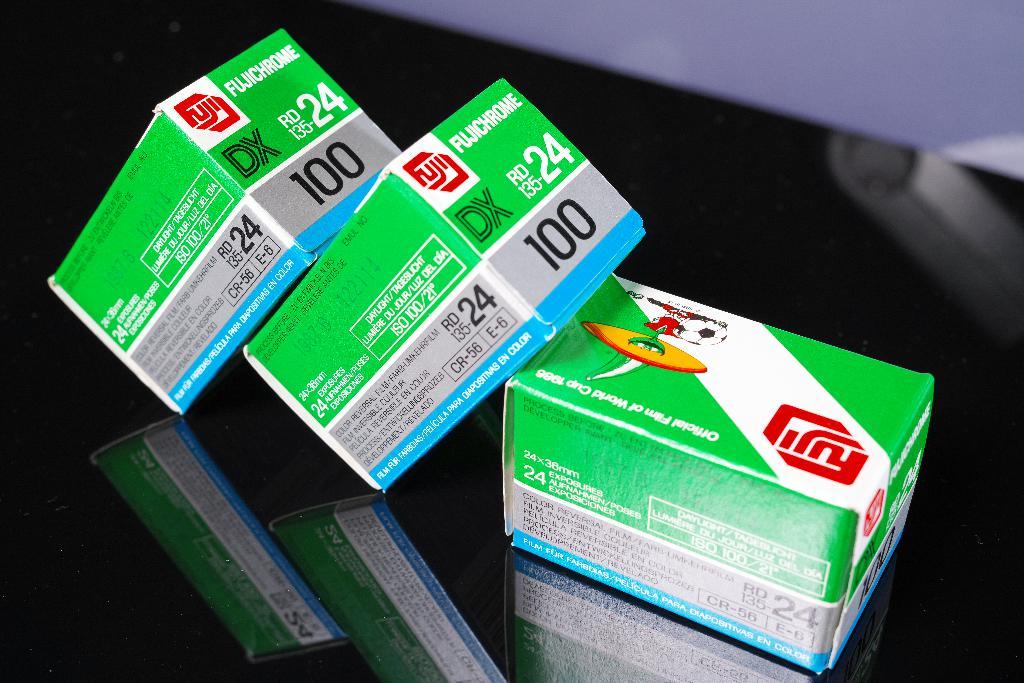How many are in each box?
Give a very brief answer. 24. What is the name of the medicine?
Make the answer very short. Unanswerable. 